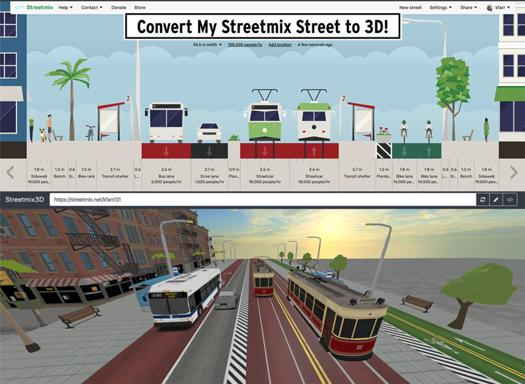What are some possible uses for this 3D conversion feature in real-world applications? This 3D conversion feature can be immensely useful in urban planning and design, helping planners and engineers to visualize traffic flow, pedestrian pathways, and the overall spatial feel of future construction projects. It’s also beneficial for community presentations and gathering feedback on proposed changes. 